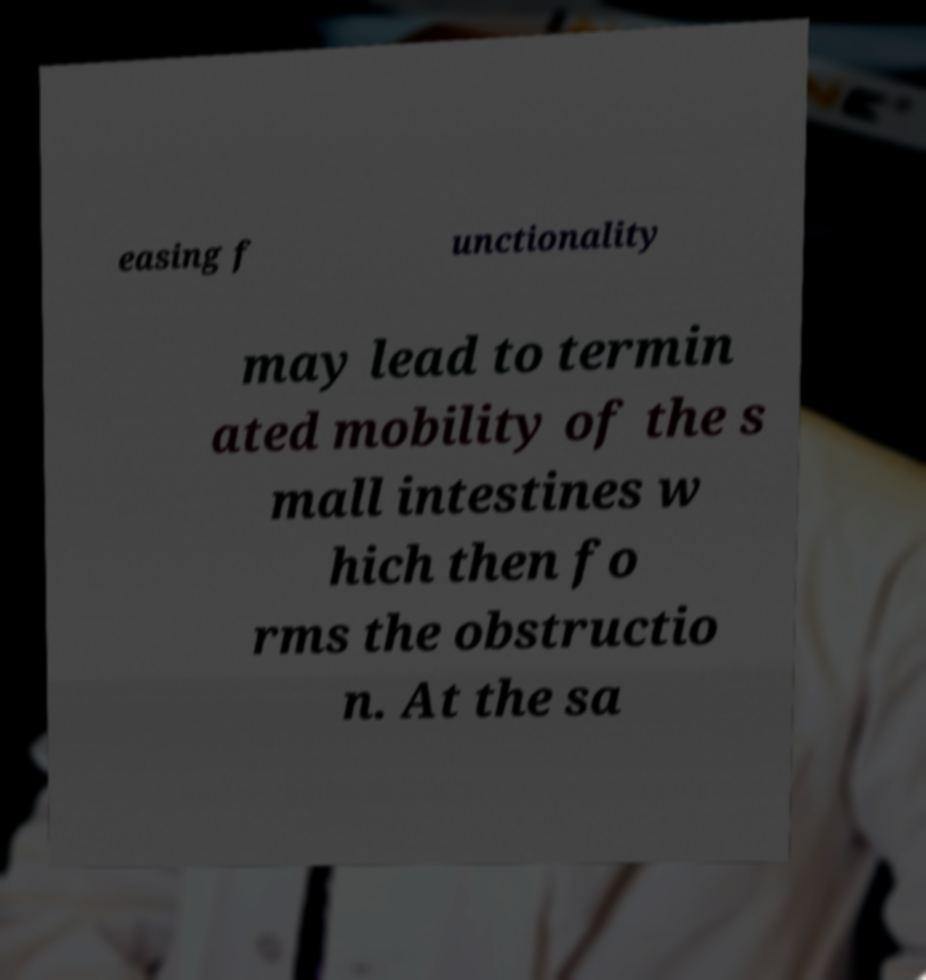Please read and relay the text visible in this image. What does it say? easing f unctionality may lead to termin ated mobility of the s mall intestines w hich then fo rms the obstructio n. At the sa 